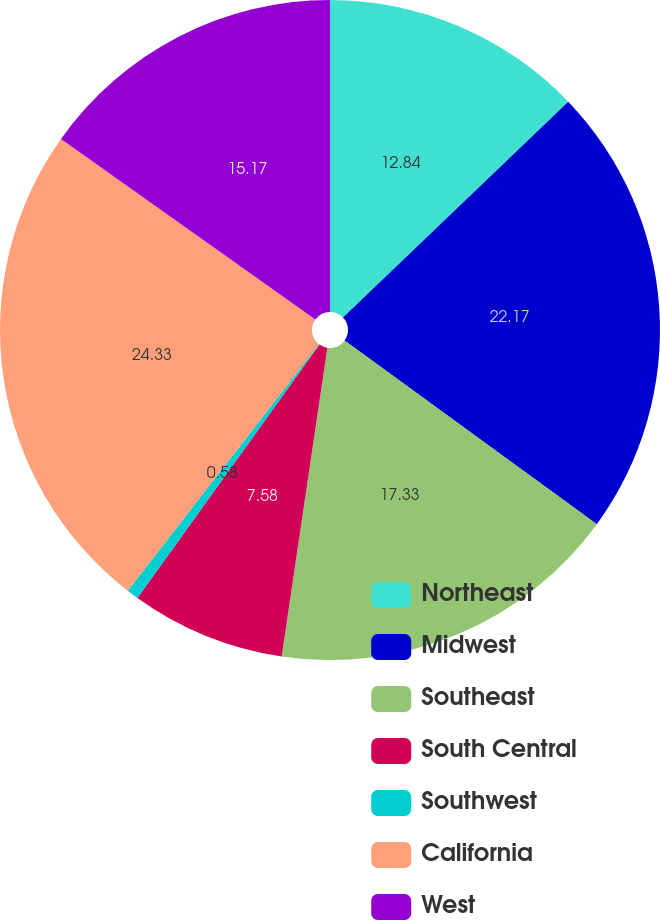<chart> <loc_0><loc_0><loc_500><loc_500><pie_chart><fcel>Northeast<fcel>Midwest<fcel>Southeast<fcel>South Central<fcel>Southwest<fcel>California<fcel>West<nl><fcel>12.84%<fcel>22.17%<fcel>17.33%<fcel>7.58%<fcel>0.58%<fcel>24.33%<fcel>15.17%<nl></chart> 